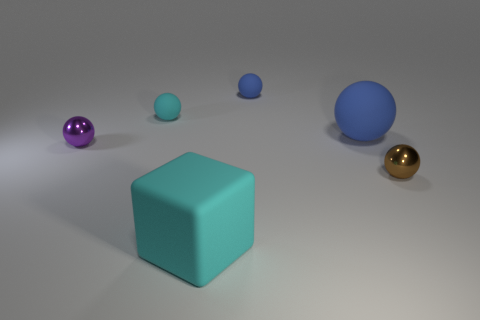What material is the object that is the same color as the big cube?
Give a very brief answer. Rubber. What number of blue things are small shiny cylinders or big blocks?
Keep it short and to the point. 0. Do the large object behind the brown shiny object and the tiny purple object have the same material?
Keep it short and to the point. No. How many other things are there of the same material as the cyan cube?
Provide a short and direct response. 3. What is the purple ball made of?
Offer a terse response. Metal. What is the size of the metal object behind the brown metallic sphere?
Make the answer very short. Small. There is a blue thing in front of the small cyan matte thing; how many small things are behind it?
Your answer should be very brief. 2. There is a small blue object right of the purple ball; is its shape the same as the cyan object on the right side of the cyan ball?
Ensure brevity in your answer.  No. How many objects are both to the left of the cyan rubber block and right of the large rubber block?
Ensure brevity in your answer.  0. Are there any tiny matte spheres of the same color as the cube?
Keep it short and to the point. Yes. 